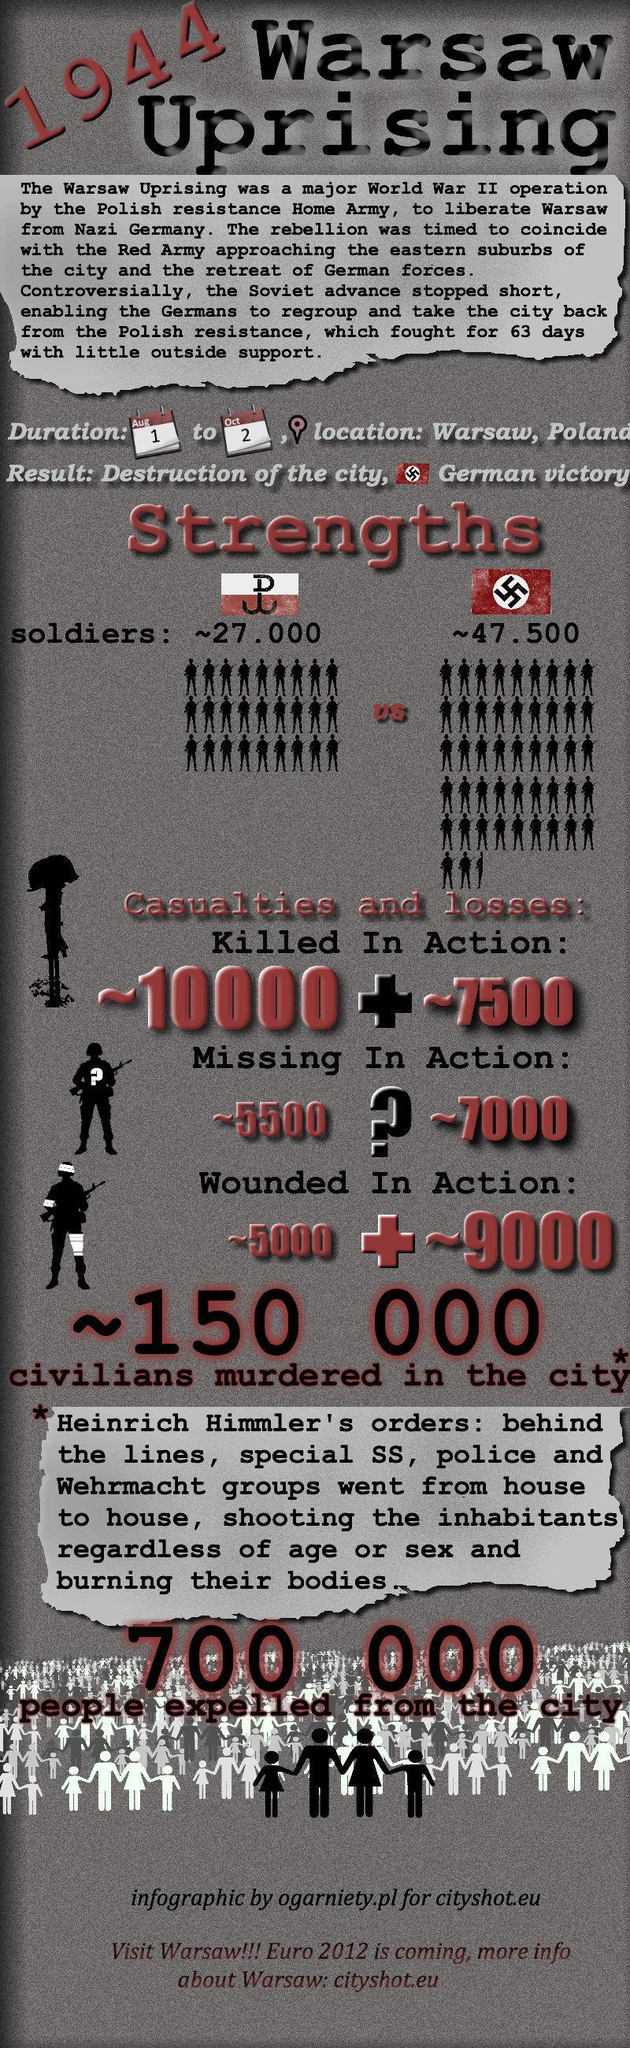what was the strength of Germany during Warsaw uprising?
Answer the question with a short phrase. 47500 How many soldiers of Poland were got injured during Warsaw uprising, approximately? 5000 How many soldiers of Poland were gone missing during Warsaw uprising, approximately? 5500 when was Warsaw uprising action ended? Oct 2 what was the strength of Poland during Warsaw uprising? 27000 How many soldiers of Germany were gone missing during Warsaw uprising, approximately? 7000 when was Warsaw uprising action started? Aug 1 How many soldiers of Poland were killed during Warsaw uprising, approximately? 10000 How many soldiers of Germany were killed during Warsaw uprising, approximately? 7500 How many soldiers of Germany were got injured during Warsaw uprising, approximately? 9000 